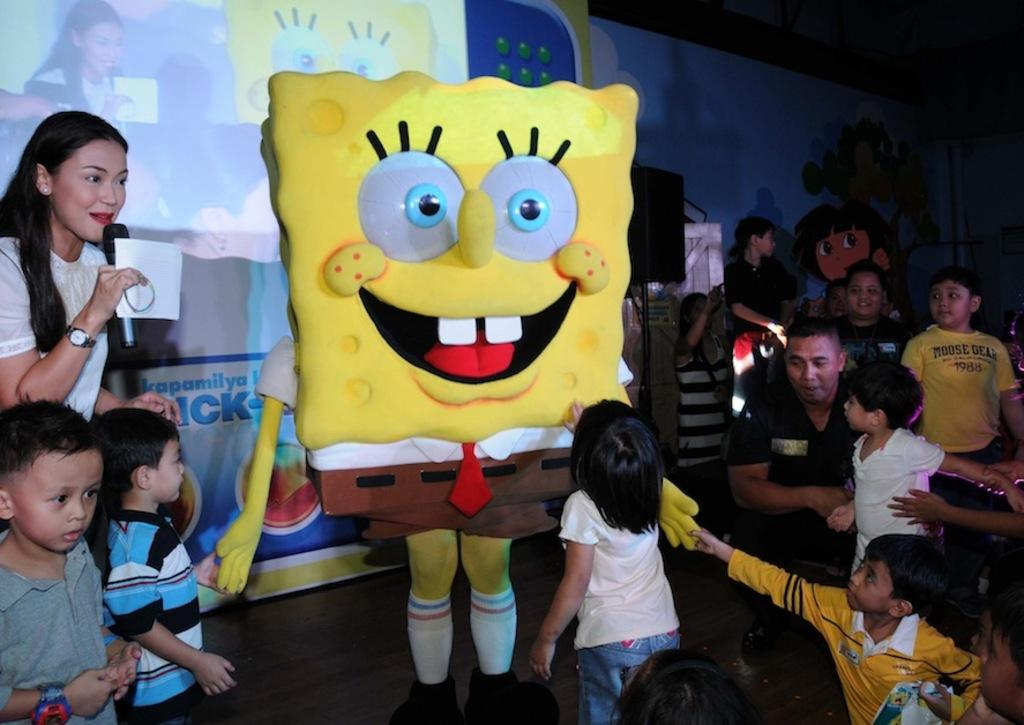What is the main subject in the center of the image? There is a mascot in the center of the image. Who is surrounding the mascot? There are children, a man, and a woman around the mascot. What can be seen in the background of the image? There is a banner and a speaker in the background of the image. What type of cake is being prepared on the stove in the image? There is no cake or stove present in the image. 